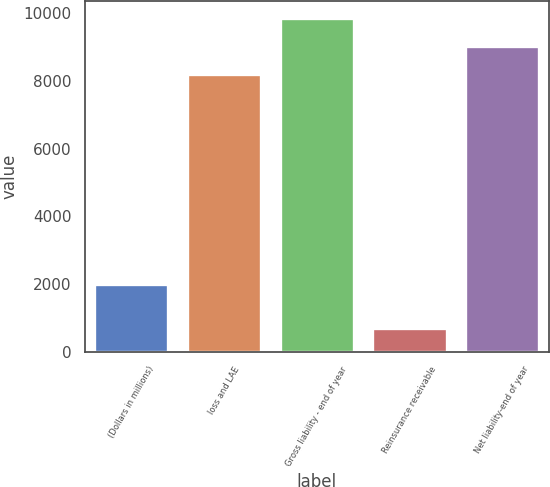<chart> <loc_0><loc_0><loc_500><loc_500><bar_chart><fcel>(Dollars in millions)<fcel>loss and LAE<fcel>Gross liability - end of year<fcel>Reinsurance receivable<fcel>Net liability-end of year<nl><fcel>2008<fcel>8214.7<fcel>9857.64<fcel>691.2<fcel>9036.17<nl></chart> 